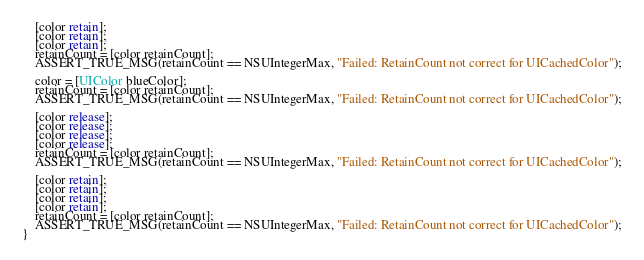<code> <loc_0><loc_0><loc_500><loc_500><_ObjectiveC_>    [color retain];
    [color retain];
    [color retain];
    retainCount = [color retainCount];
    ASSERT_TRUE_MSG(retainCount == NSUIntegerMax, "Failed: RetainCount not correct for UICachedColor");

    color = [UIColor blueColor];
    retainCount = [color retainCount];
    ASSERT_TRUE_MSG(retainCount == NSUIntegerMax, "Failed: RetainCount not correct for UICachedColor");

    [color release];
    [color release];
    [color release];
    [color release];
    retainCount = [color retainCount];
    ASSERT_TRUE_MSG(retainCount == NSUIntegerMax, "Failed: RetainCount not correct for UICachedColor");

    [color retain];
    [color retain];
    [color retain];
    [color retain];
    retainCount = [color retainCount];
    ASSERT_TRUE_MSG(retainCount == NSUIntegerMax, "Failed: RetainCount not correct for UICachedColor");
}</code> 